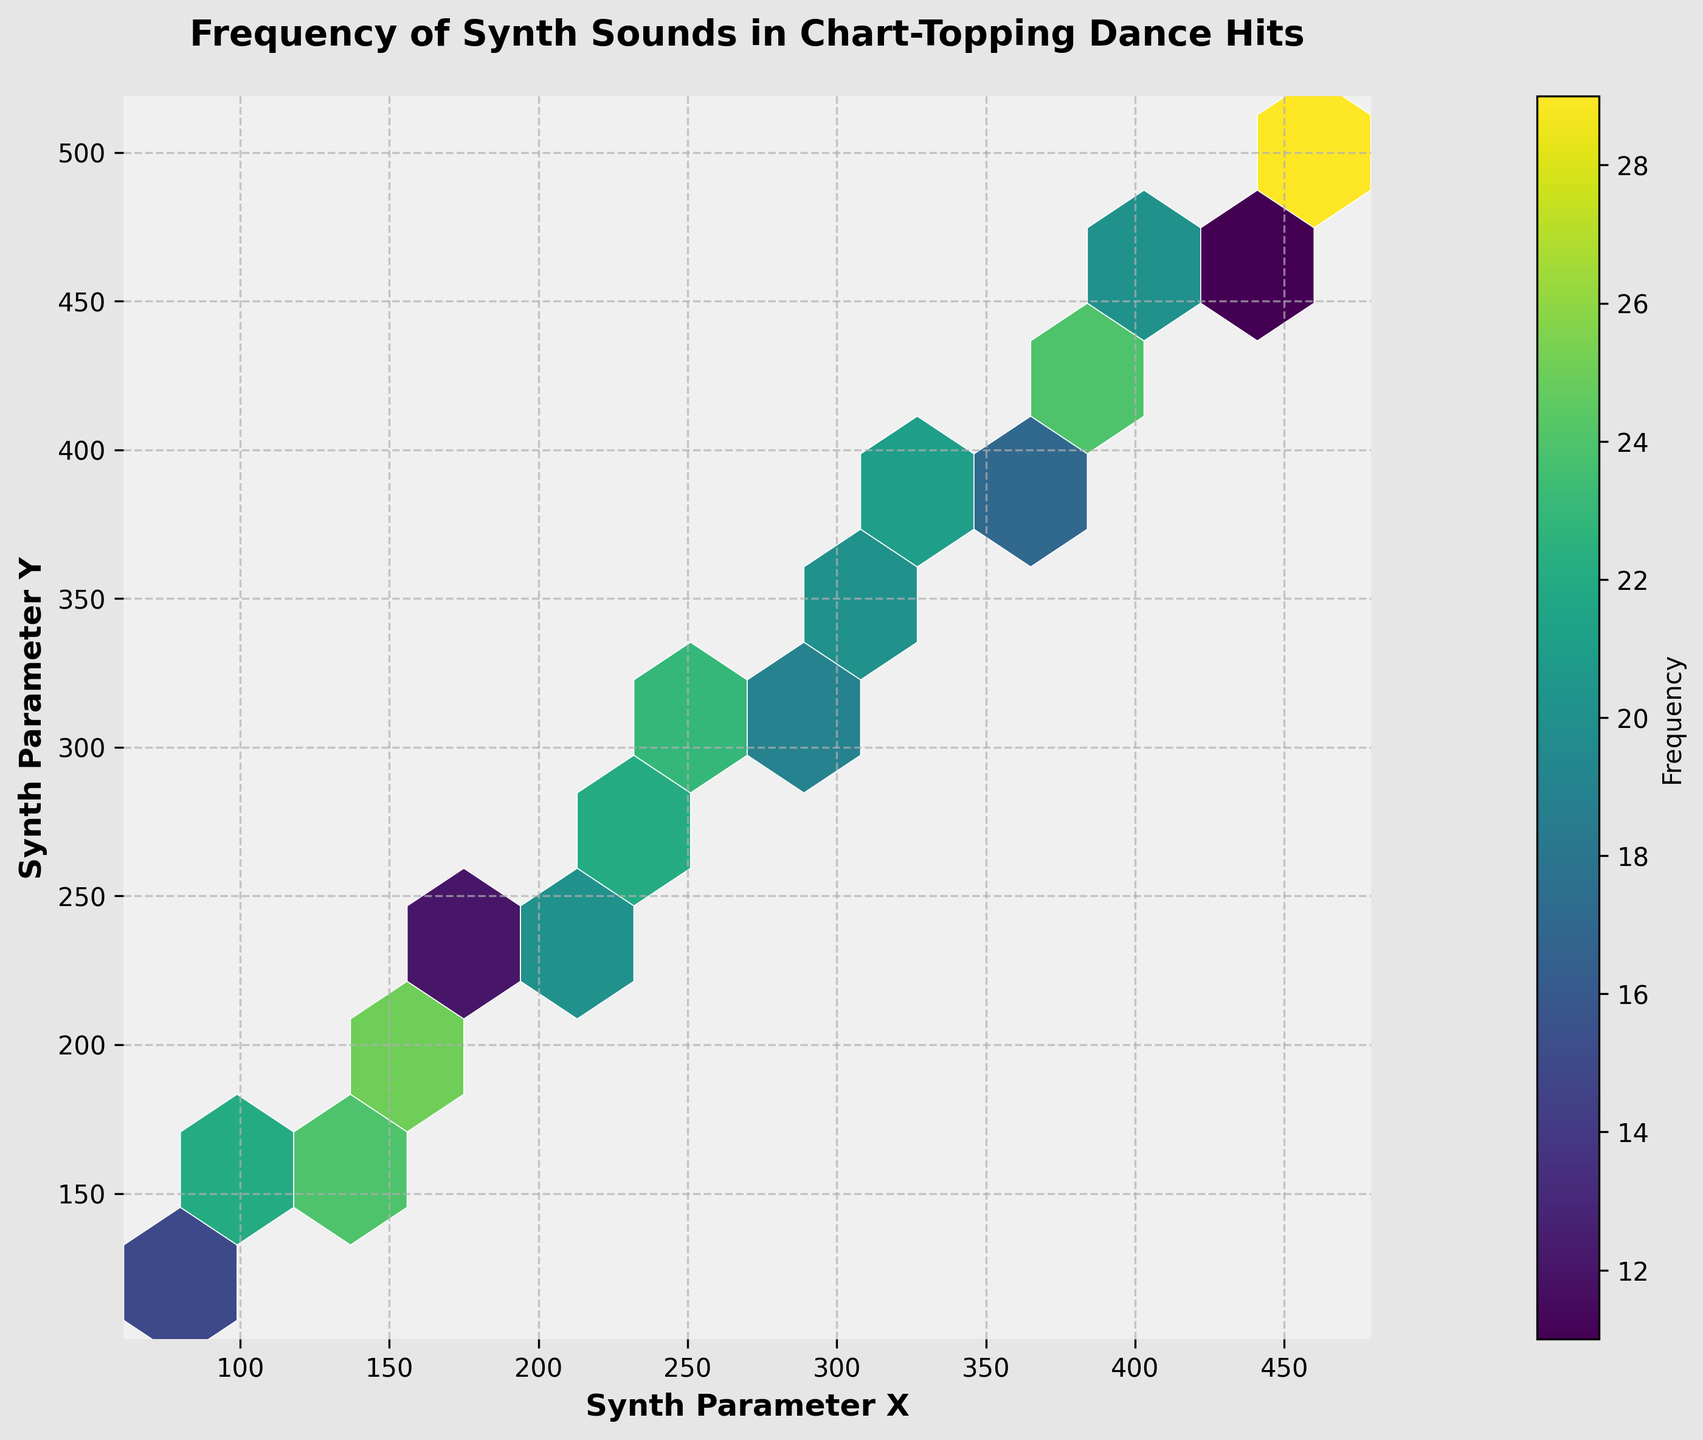What's the title of the figure? The title of the figure is typically positioned at the top center of the plot. It reads 'Frequency of Synth Sounds in Chart-Topping Dance Hits'.
Answer: Frequency of Synth Sounds in Chart-Topping Dance Hits What are the labels of the x and y axes? The x and y axes are labeled at their respective horizontal and vertical positions near the plot area. The x-axis label is 'Synth Parameter X' and the y-axis label is 'Synth Parameter Y'.
Answer: Synth Parameter X, Synth Parameter Y What is the color used for the hexagons in the plot? The color for the hexagons in the plot comes from the 'viridis' colormap, which typically includes a range of colors from purple to yellow.
Answer: Various shades from purple to yellow How many distinct regions in the hexbin plot have the highest frequency range? By checking the color intensity and referring to the color bar for 'Frequency', the hexagons with the highest frequencies are the most saturated in color. There appear to be two hexagons that stand out in frequency.
Answer: 2 Which synth parameter values (x, y) have the highest frequency? To determine the highest frequency, we locate the hexagons with the highest color intensity, then refer to the color bar and labels. The hexagons at (120, 160) and (460, 500) show the darkest colors, indicating the highest frequency.
Answer: (120, 160), (460, 500) What is the color of the figure background? The background color of the figure is noted in the prompt. The plot's background is a light gray color, referred to as '#f0f0f0', and the padding area around the plot is '#e6e6e6'.
Answer: Light gray How many synth parameter pairs have a frequency greater than 25? Refer to the color bar to determine the shades corresponding to frequencies greater than 25 and count the relevant hexagons on the plot. After counting, we find there are three pairs.
Answer: 3 What is the average frequency of the synth sounds used, based on the given data points? Sum the frequency values from the data and divide by the number of data points. The total frequency is 431, and there are 20 data points, so the average frequency is 431/20.
Answer: 21.55 Compare the frequencies for the synth parameters (160, 200) and (420, 460). Which one is higher? Locate the color intensity for both pairs and refer to the frequency scale. The frequency for (420, 460) is 27 while for (160, 200) is 25. Therefore, (420, 460) is higher.
Answer: (420, 460) What is the frequency range represented in the color bar? The color bar ranges start from the lowest frequency to the highest marked along the bar. It starts from 10 and stretches up to nearly 30, covering a range of 20.
Answer: 10 to 29 